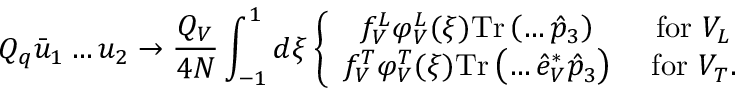<formula> <loc_0><loc_0><loc_500><loc_500>Q _ { q } \bar { u } _ { 1 } \dots u _ { 2 } \to \frac { Q _ { V } } { 4 N } \int _ { - 1 } ^ { 1 } d \xi \left \{ \begin{array} { c c c } { { f _ { V } ^ { L } \varphi _ { V } ^ { L } ( \xi ) T r \left ( \dots \hat { p } _ { 3 } \right ) } } & { { f o r V _ { L } } } \\ { { f _ { V } ^ { T } \varphi _ { V } ^ { T } ( \xi ) T r \left ( \dots \hat { e } _ { V } ^ { * } \hat { p } _ { 3 } \right ) } } & { { f o r V _ { T } . } } \end{array}</formula> 